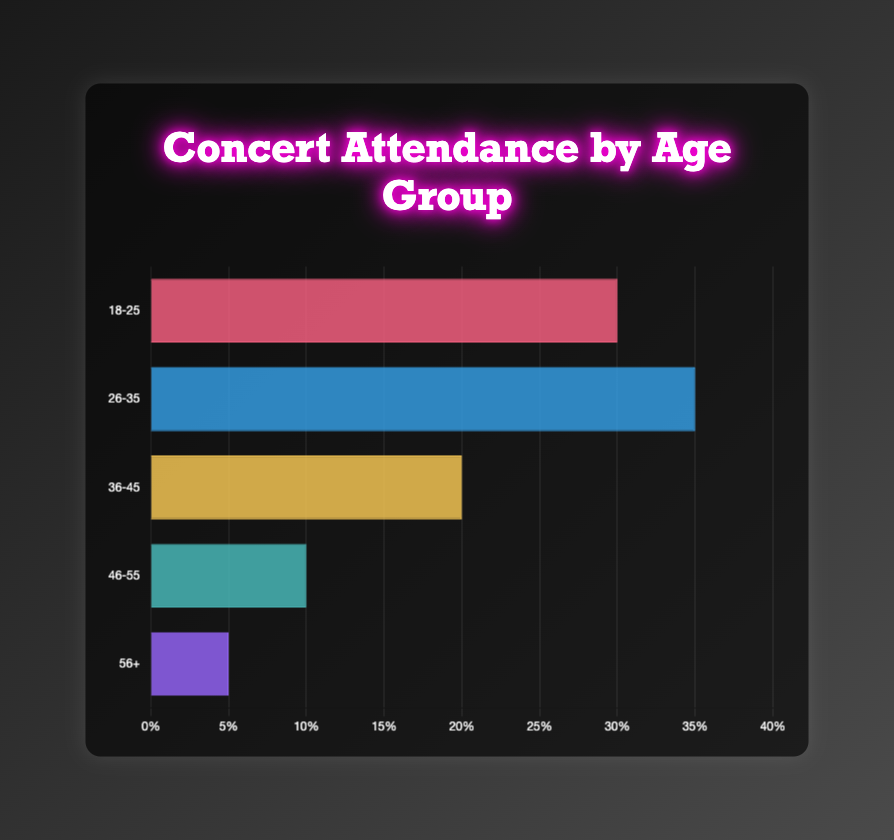What's the attendance percentage for the age group 26-35? The attendance percentage for the age group 26-35 is shown directly on the figure.
Answer: 35% Which age group has the lowest attendance percentage? Observing the chart, the bar representing the age group 56+ is the shortest, indicating the lowest attendance percentage.
Answer: 56+ How much higher is the attendance percentage for the age group 18-25 compared to the age group 46-55? The attendance percentage for 18-25 is 30%, and for 46-55, it's 10%. Subtract 10 from 30 to get the difference.
Answer: 20% Which age group has the highest attendance percentage? The longest bar represents the age group 26-35, indicating it has the highest attendance percentage.
Answer: 26-35 What is the total attendance percentage for all age groups combined? Add the attendance percentages: 30% (18-25) + 35% (26-35) + 20% (36-45) + 10% (46-55) + 5% (56+). The total is 30 + 35 + 20 + 10 + 5.
Answer: 100% Is the attendance percentage for the age group 36-45 greater than that for the age group 46-55? The attendance percentage for 36-45 is 20%, and for 46-55 it is 10%. Comparing these values, 20% is greater than 10%.
Answer: Yes What is the average attendance percentage across all age groups? Sum all the percentages (30 + 35 + 20 + 10 + 5) which equals 100, then divide by the number of age groups (5). 100 / 5 = 20.
Answer: 20% How much is the attendance percentage for the age group 46-55 lower than the average attendance percentage across all age groups? The average attendance percentage is 20%. The attendance percentage for 46-55 is 10%. Subtract 10 from 20.
Answer: 10% Which age groups have an attendance percentage lower than 20%? Bars representing age groups 46-55 and 56+ are both visibly shorter than those for 20%, indicating they have percentages lower than 20%.
Answer: 46-55, 56+ Which bar is green in the chart? The bar for the age group 36-45 is represented in a particular color, which can be described as green.
Answer: 36-45 